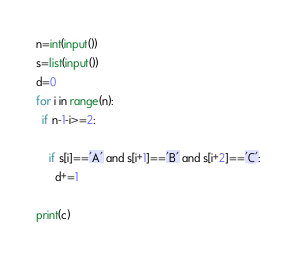<code> <loc_0><loc_0><loc_500><loc_500><_Python_>n=int(input())
s=list(input())
d=0
for i in range(n):
  if n-1-i>=2:
    
    if s[i]=='A' and s[i+1]=='B' and s[i+2]=='C':
      d+=1
  
print(c)    
</code> 